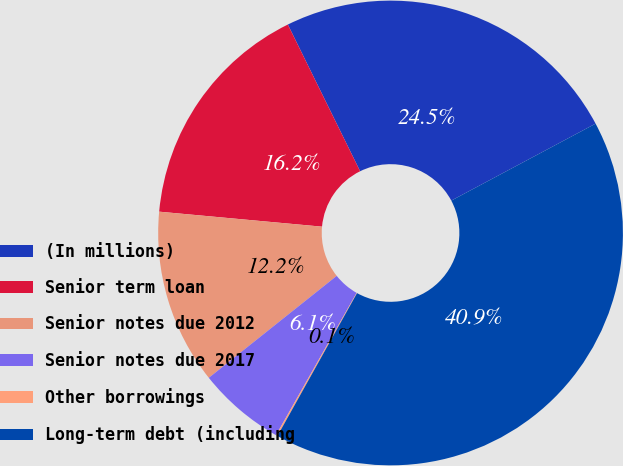<chart> <loc_0><loc_0><loc_500><loc_500><pie_chart><fcel>(In millions)<fcel>Senior term loan<fcel>Senior notes due 2012<fcel>Senior notes due 2017<fcel>Other borrowings<fcel>Long-term debt (including<nl><fcel>24.49%<fcel>16.25%<fcel>12.17%<fcel>6.09%<fcel>0.11%<fcel>40.89%<nl></chart> 